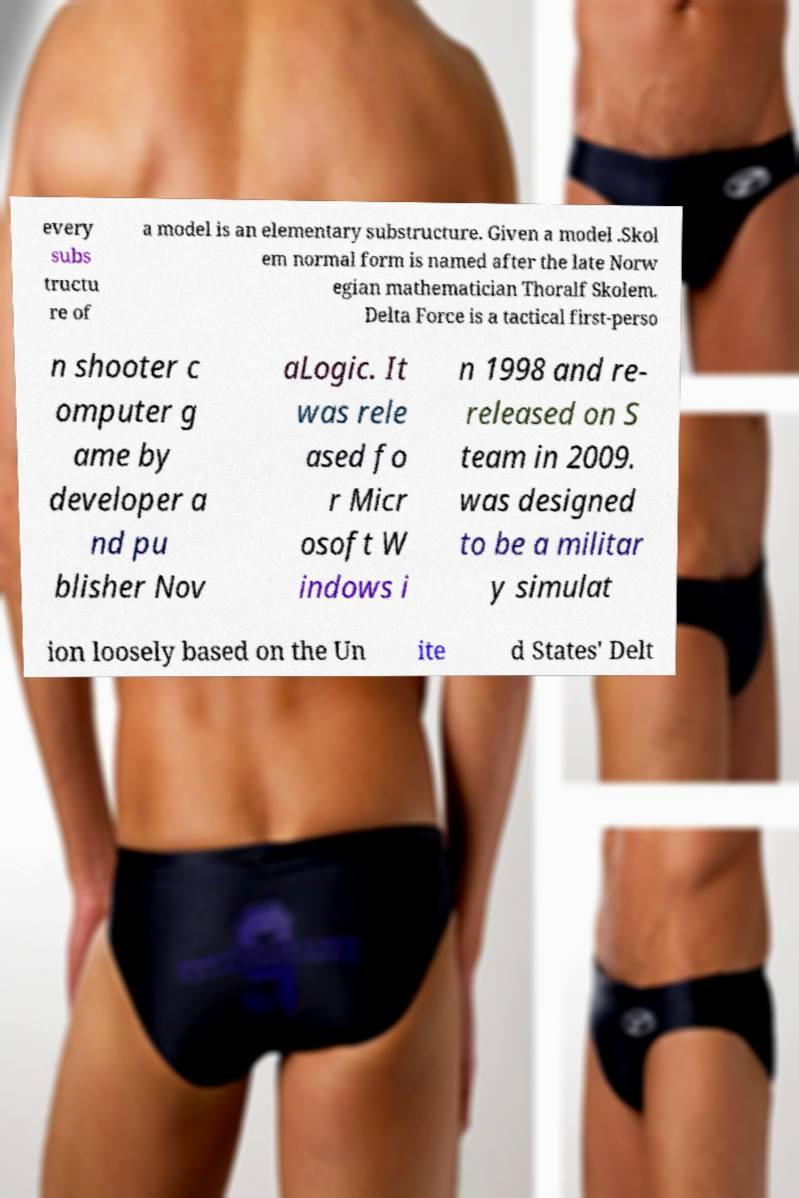Can you read and provide the text displayed in the image?This photo seems to have some interesting text. Can you extract and type it out for me? every subs tructu re of a model is an elementary substructure. Given a model .Skol em normal form is named after the late Norw egian mathematician Thoralf Skolem. Delta Force is a tactical first-perso n shooter c omputer g ame by developer a nd pu blisher Nov aLogic. It was rele ased fo r Micr osoft W indows i n 1998 and re- released on S team in 2009. was designed to be a militar y simulat ion loosely based on the Un ite d States' Delt 